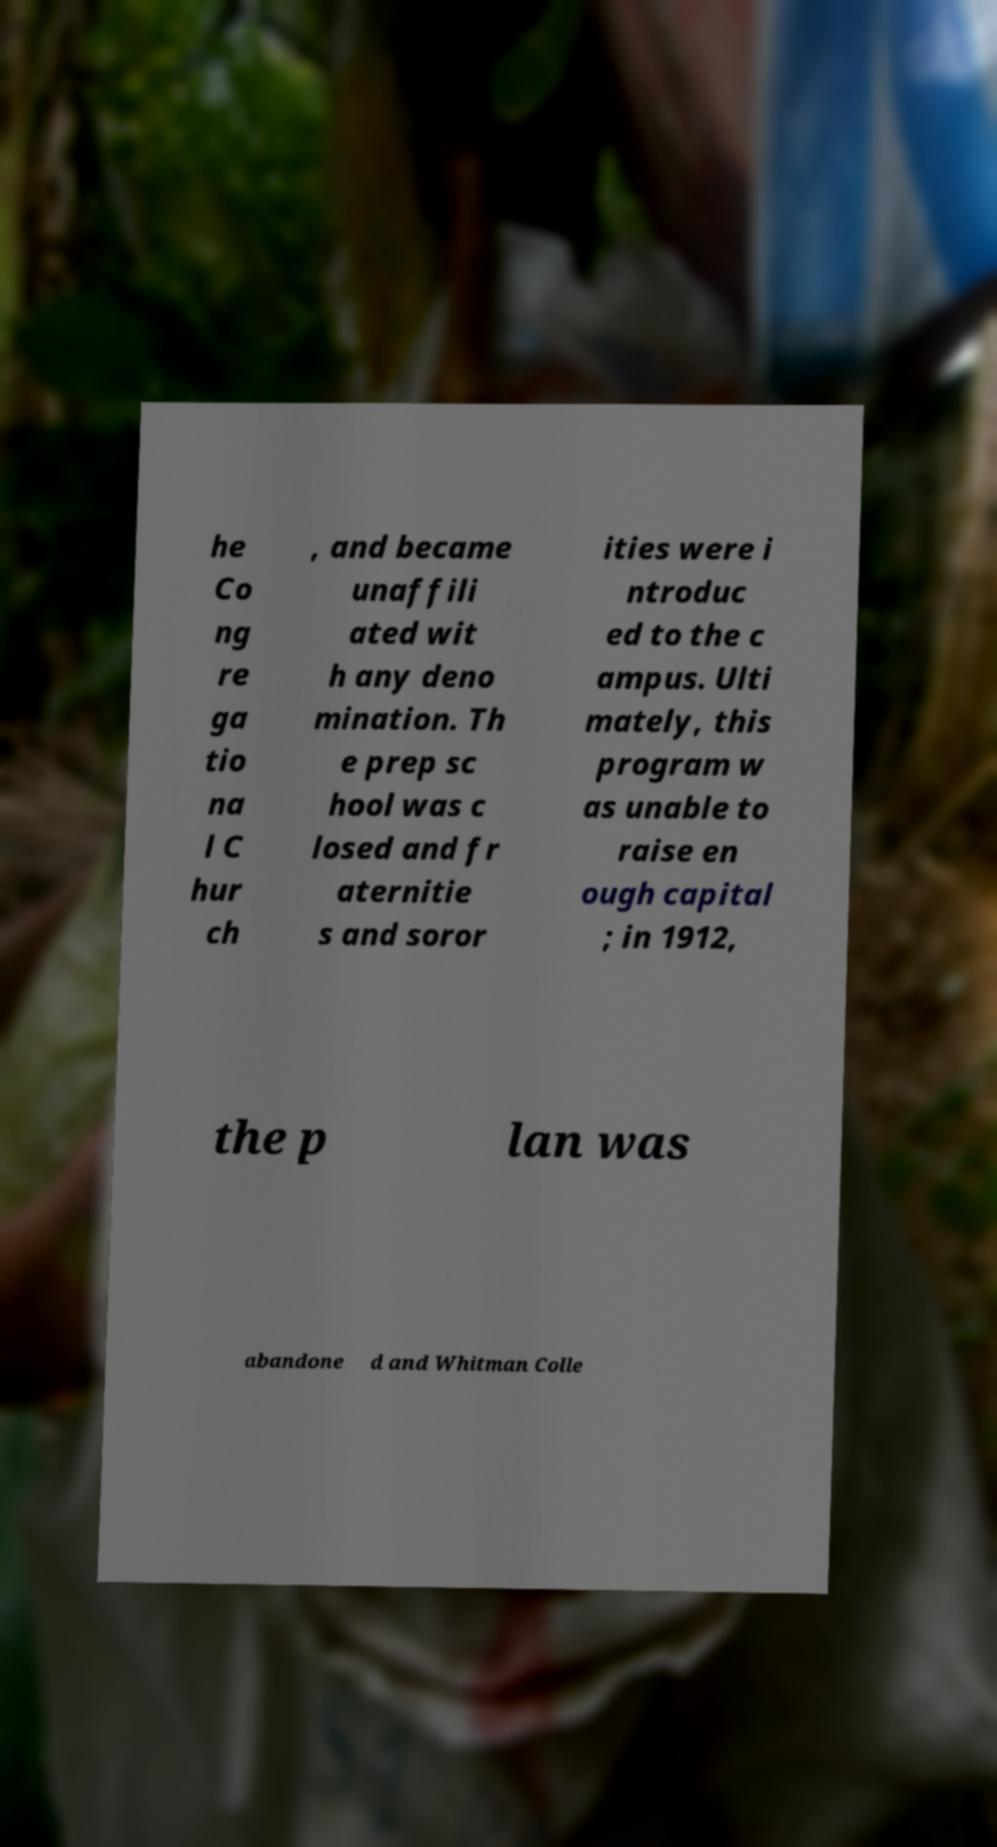Please identify and transcribe the text found in this image. he Co ng re ga tio na l C hur ch , and became unaffili ated wit h any deno mination. Th e prep sc hool was c losed and fr aternitie s and soror ities were i ntroduc ed to the c ampus. Ulti mately, this program w as unable to raise en ough capital ; in 1912, the p lan was abandone d and Whitman Colle 